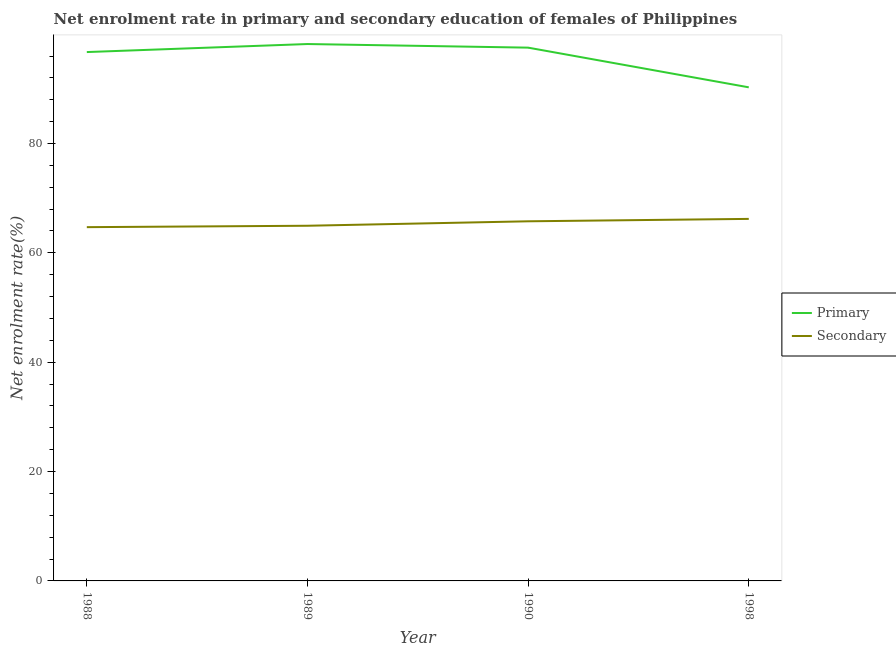How many different coloured lines are there?
Your response must be concise. 2. What is the enrollment rate in primary education in 1990?
Provide a short and direct response. 97.53. Across all years, what is the maximum enrollment rate in primary education?
Your response must be concise. 98.19. Across all years, what is the minimum enrollment rate in primary education?
Make the answer very short. 90.27. In which year was the enrollment rate in primary education maximum?
Provide a succinct answer. 1989. What is the total enrollment rate in primary education in the graph?
Your answer should be very brief. 382.72. What is the difference between the enrollment rate in primary education in 1988 and that in 1990?
Provide a succinct answer. -0.81. What is the difference between the enrollment rate in primary education in 1989 and the enrollment rate in secondary education in 1990?
Your response must be concise. 32.42. What is the average enrollment rate in primary education per year?
Make the answer very short. 95.68. In the year 1988, what is the difference between the enrollment rate in secondary education and enrollment rate in primary education?
Your response must be concise. -32.02. In how many years, is the enrollment rate in primary education greater than 36 %?
Your answer should be compact. 4. What is the ratio of the enrollment rate in primary education in 1989 to that in 1998?
Offer a terse response. 1.09. Is the enrollment rate in secondary education in 1989 less than that in 1990?
Provide a short and direct response. Yes. Is the difference between the enrollment rate in primary education in 1990 and 1998 greater than the difference between the enrollment rate in secondary education in 1990 and 1998?
Keep it short and to the point. Yes. What is the difference between the highest and the second highest enrollment rate in secondary education?
Ensure brevity in your answer.  0.44. What is the difference between the highest and the lowest enrollment rate in primary education?
Your response must be concise. 7.92. In how many years, is the enrollment rate in secondary education greater than the average enrollment rate in secondary education taken over all years?
Ensure brevity in your answer.  2. Is the enrollment rate in primary education strictly less than the enrollment rate in secondary education over the years?
Your response must be concise. No. How many years are there in the graph?
Provide a succinct answer. 4. What is the difference between two consecutive major ticks on the Y-axis?
Offer a terse response. 20. Are the values on the major ticks of Y-axis written in scientific E-notation?
Give a very brief answer. No. Where does the legend appear in the graph?
Offer a very short reply. Center right. How many legend labels are there?
Your answer should be very brief. 2. How are the legend labels stacked?
Provide a succinct answer. Vertical. What is the title of the graph?
Give a very brief answer. Net enrolment rate in primary and secondary education of females of Philippines. Does "Urban" appear as one of the legend labels in the graph?
Provide a short and direct response. No. What is the label or title of the X-axis?
Your answer should be compact. Year. What is the label or title of the Y-axis?
Your response must be concise. Net enrolment rate(%). What is the Net enrolment rate(%) of Primary in 1988?
Offer a very short reply. 96.72. What is the Net enrolment rate(%) in Secondary in 1988?
Your response must be concise. 64.7. What is the Net enrolment rate(%) in Primary in 1989?
Offer a very short reply. 98.19. What is the Net enrolment rate(%) of Secondary in 1989?
Provide a short and direct response. 64.96. What is the Net enrolment rate(%) in Primary in 1990?
Keep it short and to the point. 97.53. What is the Net enrolment rate(%) of Secondary in 1990?
Your answer should be very brief. 65.77. What is the Net enrolment rate(%) of Primary in 1998?
Your answer should be compact. 90.27. What is the Net enrolment rate(%) in Secondary in 1998?
Offer a terse response. 66.21. Across all years, what is the maximum Net enrolment rate(%) in Primary?
Ensure brevity in your answer.  98.19. Across all years, what is the maximum Net enrolment rate(%) of Secondary?
Make the answer very short. 66.21. Across all years, what is the minimum Net enrolment rate(%) in Primary?
Keep it short and to the point. 90.27. Across all years, what is the minimum Net enrolment rate(%) of Secondary?
Offer a very short reply. 64.7. What is the total Net enrolment rate(%) of Primary in the graph?
Provide a succinct answer. 382.72. What is the total Net enrolment rate(%) of Secondary in the graph?
Provide a short and direct response. 261.64. What is the difference between the Net enrolment rate(%) of Primary in 1988 and that in 1989?
Provide a short and direct response. -1.47. What is the difference between the Net enrolment rate(%) in Secondary in 1988 and that in 1989?
Your answer should be very brief. -0.26. What is the difference between the Net enrolment rate(%) in Primary in 1988 and that in 1990?
Give a very brief answer. -0.81. What is the difference between the Net enrolment rate(%) of Secondary in 1988 and that in 1990?
Give a very brief answer. -1.07. What is the difference between the Net enrolment rate(%) of Primary in 1988 and that in 1998?
Offer a very short reply. 6.45. What is the difference between the Net enrolment rate(%) in Secondary in 1988 and that in 1998?
Ensure brevity in your answer.  -1.51. What is the difference between the Net enrolment rate(%) in Primary in 1989 and that in 1990?
Ensure brevity in your answer.  0.66. What is the difference between the Net enrolment rate(%) in Secondary in 1989 and that in 1990?
Your answer should be very brief. -0.81. What is the difference between the Net enrolment rate(%) of Primary in 1989 and that in 1998?
Keep it short and to the point. 7.92. What is the difference between the Net enrolment rate(%) in Secondary in 1989 and that in 1998?
Provide a short and direct response. -1.26. What is the difference between the Net enrolment rate(%) in Primary in 1990 and that in 1998?
Ensure brevity in your answer.  7.26. What is the difference between the Net enrolment rate(%) in Secondary in 1990 and that in 1998?
Ensure brevity in your answer.  -0.44. What is the difference between the Net enrolment rate(%) in Primary in 1988 and the Net enrolment rate(%) in Secondary in 1989?
Your response must be concise. 31.77. What is the difference between the Net enrolment rate(%) of Primary in 1988 and the Net enrolment rate(%) of Secondary in 1990?
Make the answer very short. 30.95. What is the difference between the Net enrolment rate(%) of Primary in 1988 and the Net enrolment rate(%) of Secondary in 1998?
Offer a very short reply. 30.51. What is the difference between the Net enrolment rate(%) of Primary in 1989 and the Net enrolment rate(%) of Secondary in 1990?
Your answer should be compact. 32.42. What is the difference between the Net enrolment rate(%) in Primary in 1989 and the Net enrolment rate(%) in Secondary in 1998?
Make the answer very short. 31.98. What is the difference between the Net enrolment rate(%) of Primary in 1990 and the Net enrolment rate(%) of Secondary in 1998?
Give a very brief answer. 31.32. What is the average Net enrolment rate(%) of Primary per year?
Give a very brief answer. 95.68. What is the average Net enrolment rate(%) in Secondary per year?
Offer a very short reply. 65.41. In the year 1988, what is the difference between the Net enrolment rate(%) in Primary and Net enrolment rate(%) in Secondary?
Your response must be concise. 32.02. In the year 1989, what is the difference between the Net enrolment rate(%) of Primary and Net enrolment rate(%) of Secondary?
Ensure brevity in your answer.  33.23. In the year 1990, what is the difference between the Net enrolment rate(%) of Primary and Net enrolment rate(%) of Secondary?
Provide a succinct answer. 31.76. In the year 1998, what is the difference between the Net enrolment rate(%) in Primary and Net enrolment rate(%) in Secondary?
Your answer should be very brief. 24.06. What is the ratio of the Net enrolment rate(%) in Secondary in 1988 to that in 1990?
Your answer should be compact. 0.98. What is the ratio of the Net enrolment rate(%) of Primary in 1988 to that in 1998?
Offer a very short reply. 1.07. What is the ratio of the Net enrolment rate(%) of Secondary in 1988 to that in 1998?
Provide a succinct answer. 0.98. What is the ratio of the Net enrolment rate(%) in Primary in 1989 to that in 1990?
Provide a succinct answer. 1.01. What is the ratio of the Net enrolment rate(%) in Secondary in 1989 to that in 1990?
Offer a very short reply. 0.99. What is the ratio of the Net enrolment rate(%) in Primary in 1989 to that in 1998?
Give a very brief answer. 1.09. What is the ratio of the Net enrolment rate(%) of Secondary in 1989 to that in 1998?
Provide a short and direct response. 0.98. What is the ratio of the Net enrolment rate(%) in Primary in 1990 to that in 1998?
Make the answer very short. 1.08. What is the difference between the highest and the second highest Net enrolment rate(%) in Primary?
Your answer should be compact. 0.66. What is the difference between the highest and the second highest Net enrolment rate(%) in Secondary?
Your answer should be compact. 0.44. What is the difference between the highest and the lowest Net enrolment rate(%) of Primary?
Provide a short and direct response. 7.92. What is the difference between the highest and the lowest Net enrolment rate(%) of Secondary?
Offer a terse response. 1.51. 